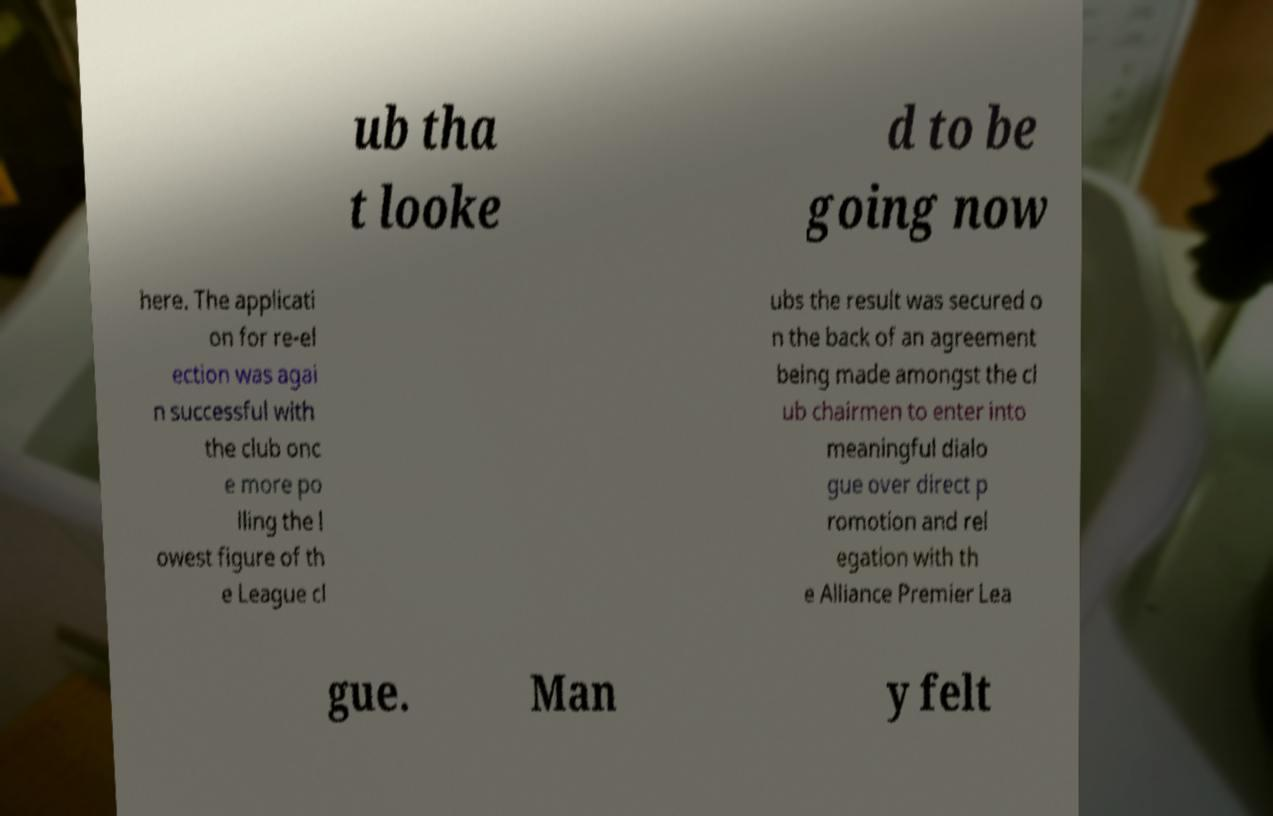Can you accurately transcribe the text from the provided image for me? ub tha t looke d to be going now here. The applicati on for re-el ection was agai n successful with the club onc e more po lling the l owest figure of th e League cl ubs the result was secured o n the back of an agreement being made amongst the cl ub chairmen to enter into meaningful dialo gue over direct p romotion and rel egation with th e Alliance Premier Lea gue. Man y felt 